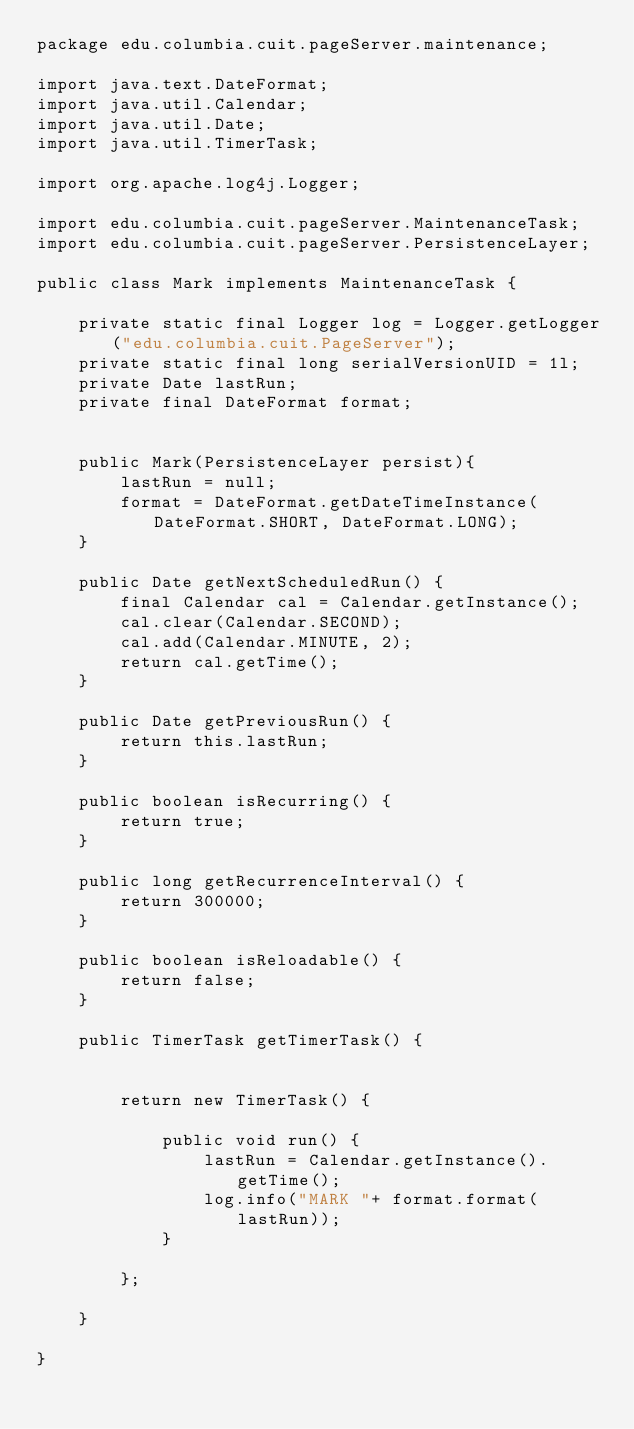Convert code to text. <code><loc_0><loc_0><loc_500><loc_500><_Java_>package edu.columbia.cuit.pageServer.maintenance;

import java.text.DateFormat;
import java.util.Calendar;
import java.util.Date;
import java.util.TimerTask;

import org.apache.log4j.Logger;

import edu.columbia.cuit.pageServer.MaintenanceTask;
import edu.columbia.cuit.pageServer.PersistenceLayer;

public class Mark implements MaintenanceTask {

	private static final Logger log = Logger.getLogger("edu.columbia.cuit.PageServer");
	private static final long serialVersionUID = 1l;
	private Date lastRun;
	private final DateFormat format;

	
	public Mark(PersistenceLayer persist){
		lastRun = null;
		format = DateFormat.getDateTimeInstance(DateFormat.SHORT, DateFormat.LONG);
	}
	
	public Date getNextScheduledRun() {
		final Calendar cal = Calendar.getInstance();
		cal.clear(Calendar.SECOND);
		cal.add(Calendar.MINUTE, 2);
		return cal.getTime();
	}

	public Date getPreviousRun() {
		return this.lastRun;
	}

	public boolean isRecurring() {
		return true;
	}

	public long getRecurrenceInterval() {
		return 300000;
	}

	public boolean isReloadable() {
		return false;
	}

	public TimerTask getTimerTask() {

		
		return new TimerTask() {
			
			public void run() {
				lastRun = Calendar.getInstance().getTime();
				log.info("MARK "+ format.format(lastRun));
			}
			   
		};
	  
	}

}
</code> 